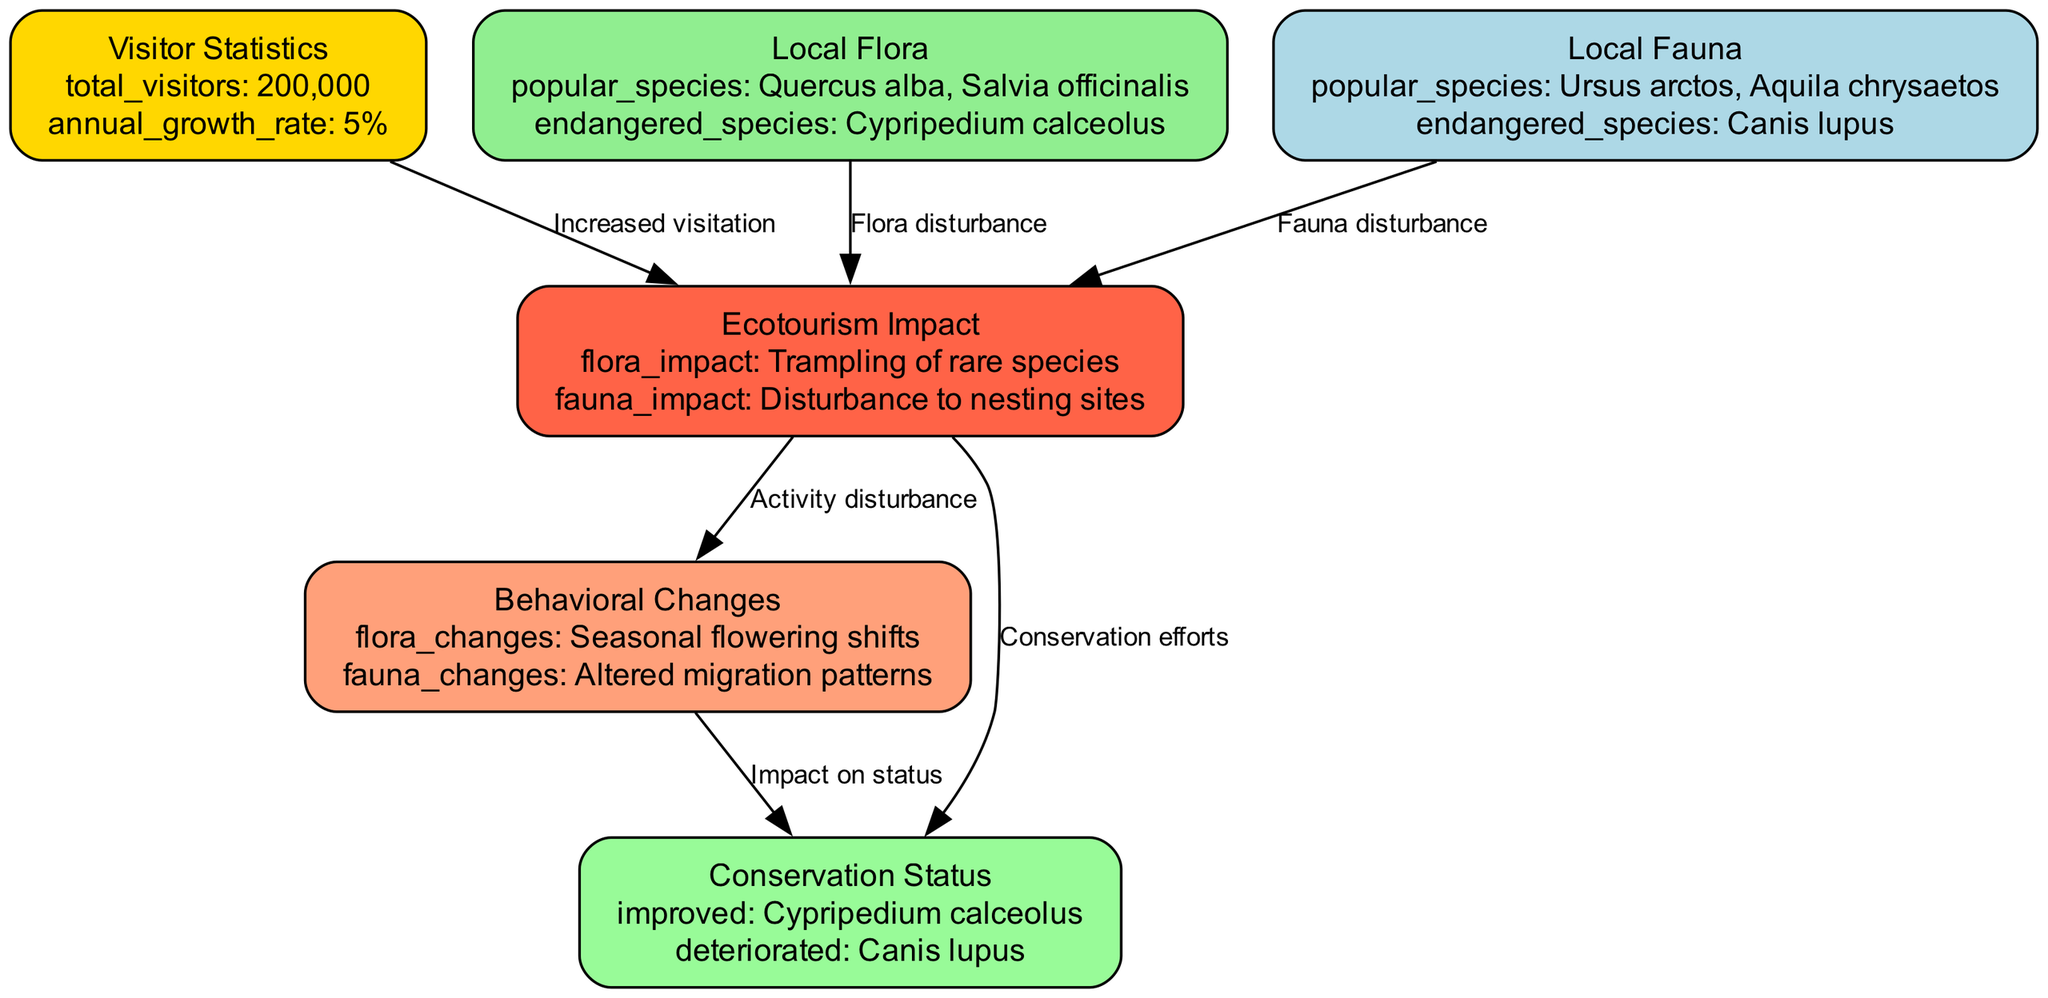What is the total number of visitors? The node labeled "Visitor Statistics" contains the detail "total_visitors" which states the total number of visitors as "200,000".
Answer: 200,000 What species are listed as endangered in local flora? The node labeled "Local Flora" specifies "endangered_species" and lists "Cypripedium calceolus" as the only species noted.
Answer: Cypripedium calceolus How does increased visitation affect local fauna? The edge labeled "Increased visitation" connects "Visitor Statistics" to "Ecotourism Impact", and the node "Ecotourism Impact" lists "Disturbance to nesting sites" under "fauna_impact". Therefore, increased visitation leads to disturbances in local fauna's nesting habitats.
Answer: Disturbance to nesting sites What is the current conservation status of Cypripedium calceolus? The node "Conservation Status" categorizes "Cypripedium calceolus" under "improved", indicating a positive change in its conservation status due to conservation efforts related to ecotourism.
Answer: Improved What impact does ecotourism have on flora? The node "Ecotourism Impact" includes "Trampling of rare species" under "flora_impact", indicating that ecotourism has a detrimental impact on plant species by causing physical damage.
Answer: Trampling of rare species How are seasonal flowering shifts classified in the diagram? "Seasonal flowering shifts" are mentioned under "flora_changes" in the "Behavioral Changes" node, indicating that changes in behavior due to ecotourism have led to shifts in the flowering seasons of local flora.
Answer: Seasonal flowering shifts What is the relationship between behavioral changes and conservation status? The edge labeled "Impact on status" connects "Behavioral Changes" to "Conservation Status", signifying that changes in behavior among flora and fauna can influence their conservation status.
Answer: Impact on status Which local fauna species is listed as endangered? The node "Local Fauna" specifies "endangered_species" and identifies "Canis lupus" as the endangered species, indicating a risk to its population likely due to human disturbances.
Answer: Canis lupus 